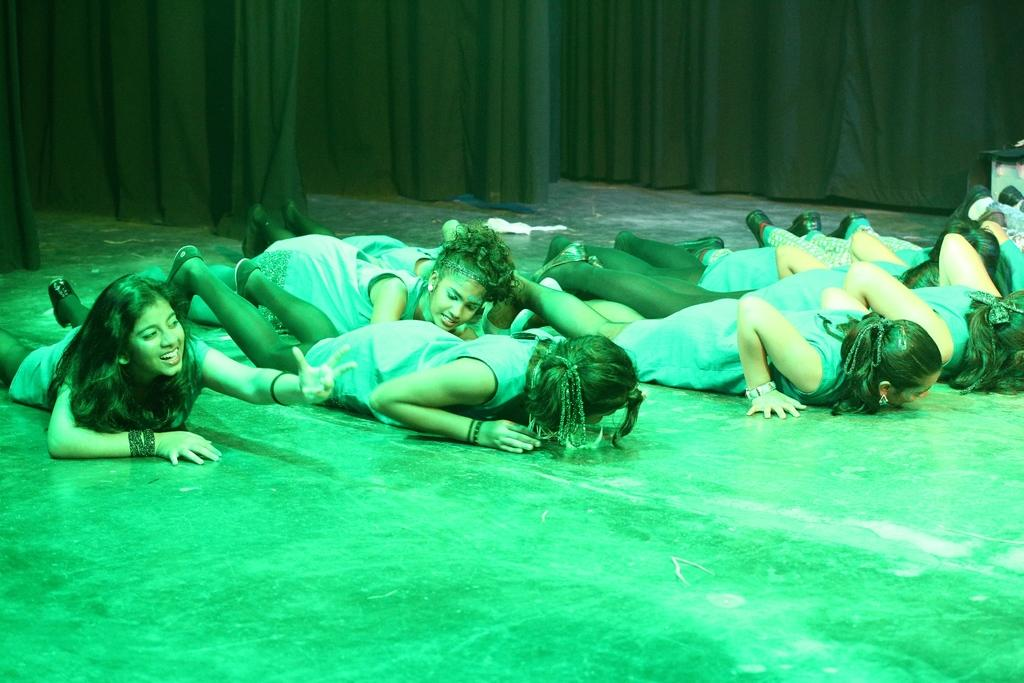What is the primary surface visible in the image? There is a floor in the image. What are the people in the image doing? The people are lying on the floor. What can be seen in the background of the image? There are curtains in the background of the image. Can you tell me how many dinosaurs are standing next to the people on the floor? There are no dinosaurs present in the image; it only features people lying on the floor and curtains in the background. 